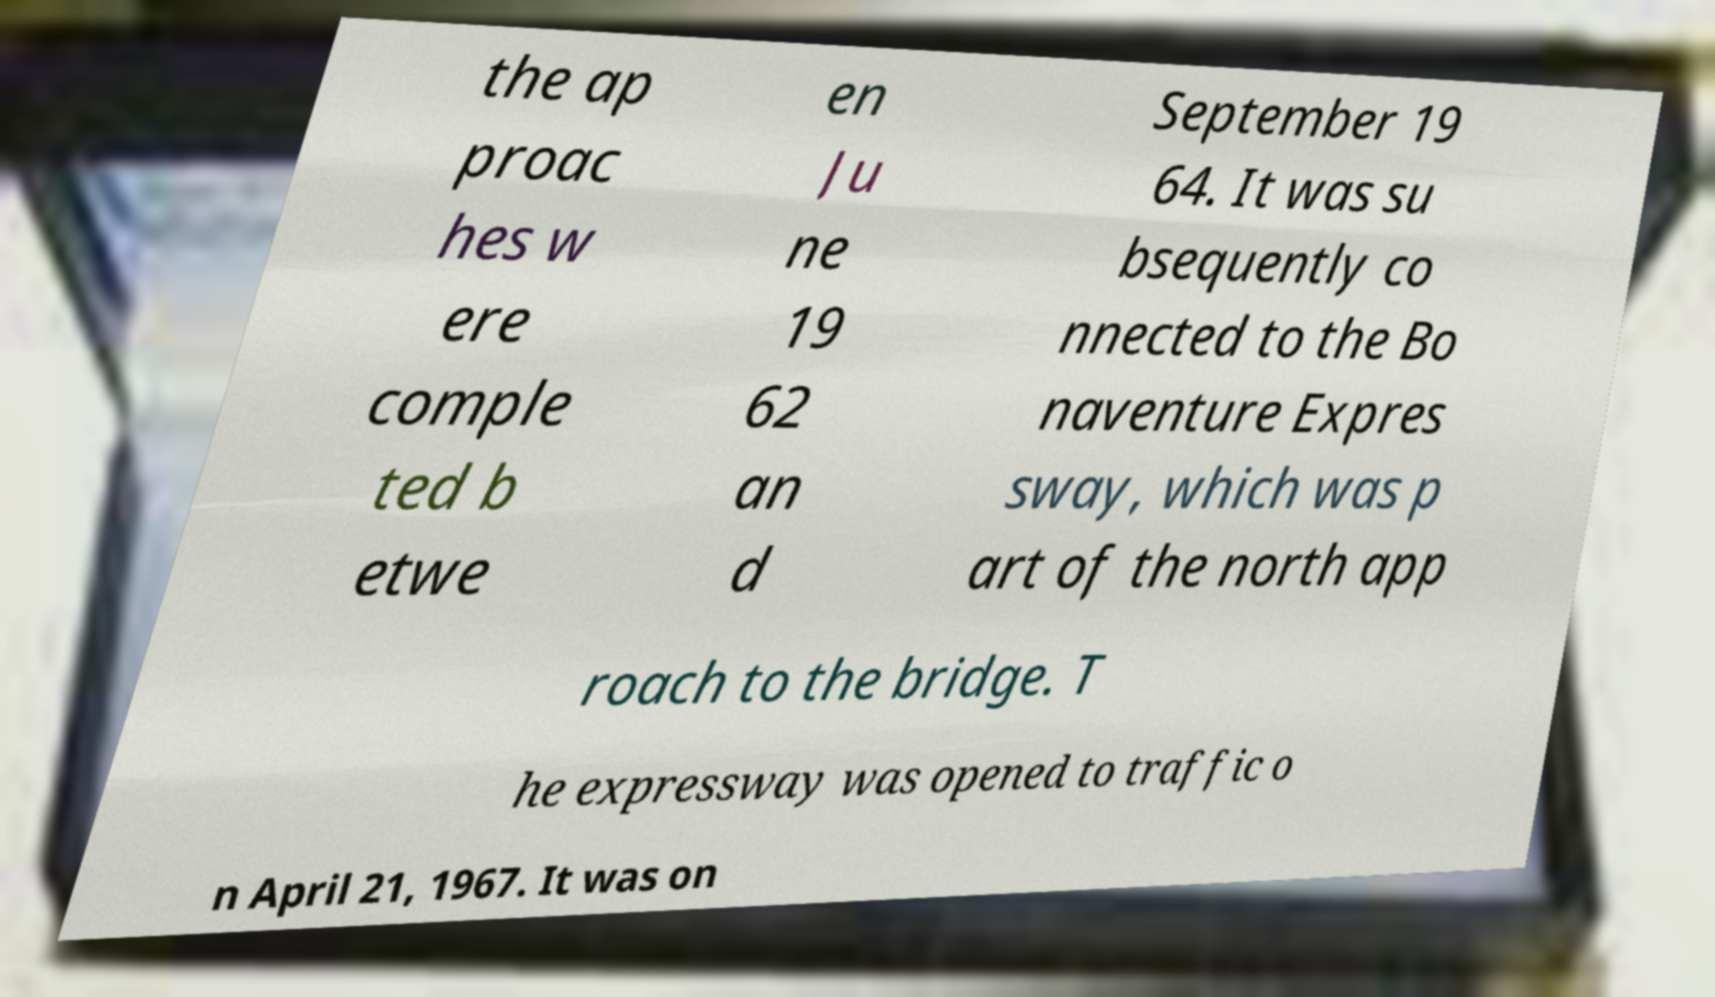What messages or text are displayed in this image? I need them in a readable, typed format. the ap proac hes w ere comple ted b etwe en Ju ne 19 62 an d September 19 64. It was su bsequently co nnected to the Bo naventure Expres sway, which was p art of the north app roach to the bridge. T he expressway was opened to traffic o n April 21, 1967. It was on 